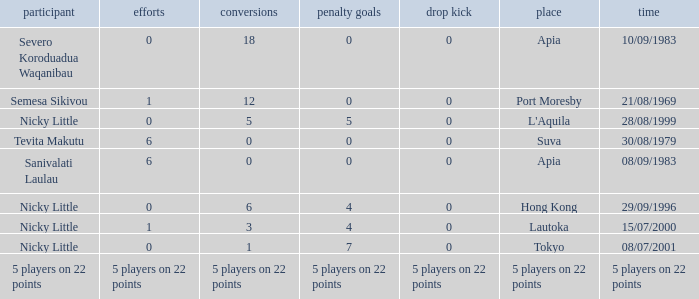How many conversions had 0 pens and 0 tries? 18.0. 